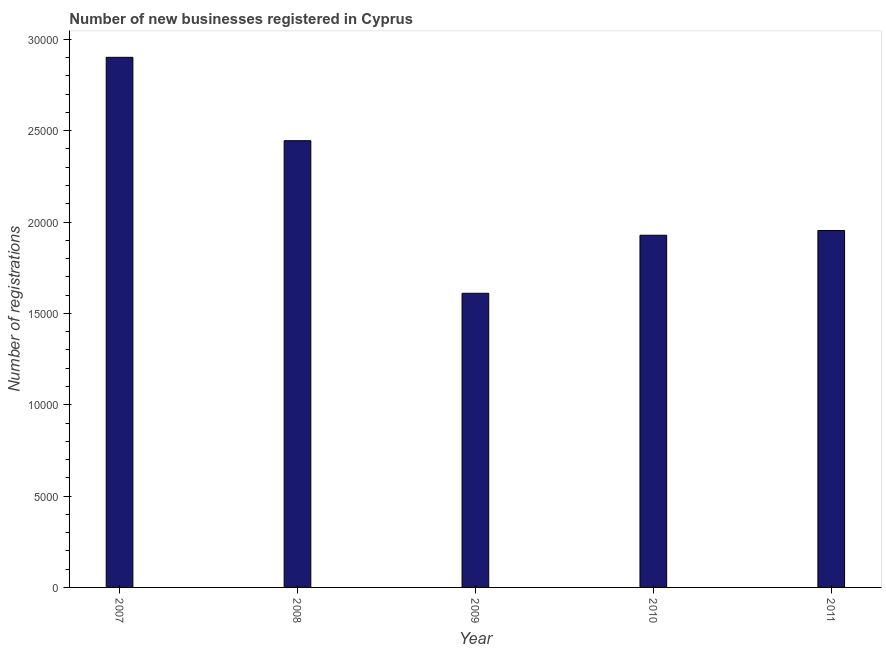Does the graph contain grids?
Your response must be concise. No. What is the title of the graph?
Provide a succinct answer. Number of new businesses registered in Cyprus. What is the label or title of the Y-axis?
Make the answer very short. Number of registrations. What is the number of new business registrations in 2010?
Give a very brief answer. 1.93e+04. Across all years, what is the maximum number of new business registrations?
Offer a very short reply. 2.90e+04. Across all years, what is the minimum number of new business registrations?
Your answer should be compact. 1.61e+04. In which year was the number of new business registrations maximum?
Provide a succinct answer. 2007. In which year was the number of new business registrations minimum?
Keep it short and to the point. 2009. What is the sum of the number of new business registrations?
Provide a succinct answer. 1.08e+05. What is the difference between the number of new business registrations in 2009 and 2011?
Your answer should be compact. -3437. What is the average number of new business registrations per year?
Your answer should be compact. 2.17e+04. What is the median number of new business registrations?
Offer a very short reply. 1.95e+04. What is the ratio of the number of new business registrations in 2007 to that in 2009?
Offer a terse response. 1.8. What is the difference between the highest and the second highest number of new business registrations?
Offer a terse response. 4563. What is the difference between the highest and the lowest number of new business registrations?
Your response must be concise. 1.29e+04. In how many years, is the number of new business registrations greater than the average number of new business registrations taken over all years?
Ensure brevity in your answer.  2. How many bars are there?
Ensure brevity in your answer.  5. Are all the bars in the graph horizontal?
Ensure brevity in your answer.  No. How many years are there in the graph?
Give a very brief answer. 5. What is the Number of registrations in 2007?
Provide a short and direct response. 2.90e+04. What is the Number of registrations in 2008?
Keep it short and to the point. 2.45e+04. What is the Number of registrations of 2009?
Ensure brevity in your answer.  1.61e+04. What is the Number of registrations in 2010?
Ensure brevity in your answer.  1.93e+04. What is the Number of registrations of 2011?
Offer a very short reply. 1.95e+04. What is the difference between the Number of registrations in 2007 and 2008?
Ensure brevity in your answer.  4563. What is the difference between the Number of registrations in 2007 and 2009?
Your answer should be very brief. 1.29e+04. What is the difference between the Number of registrations in 2007 and 2010?
Your answer should be very brief. 9738. What is the difference between the Number of registrations in 2007 and 2011?
Ensure brevity in your answer.  9478. What is the difference between the Number of registrations in 2008 and 2009?
Keep it short and to the point. 8352. What is the difference between the Number of registrations in 2008 and 2010?
Offer a terse response. 5175. What is the difference between the Number of registrations in 2008 and 2011?
Make the answer very short. 4915. What is the difference between the Number of registrations in 2009 and 2010?
Provide a succinct answer. -3177. What is the difference between the Number of registrations in 2009 and 2011?
Keep it short and to the point. -3437. What is the difference between the Number of registrations in 2010 and 2011?
Give a very brief answer. -260. What is the ratio of the Number of registrations in 2007 to that in 2008?
Your answer should be very brief. 1.19. What is the ratio of the Number of registrations in 2007 to that in 2009?
Offer a terse response. 1.8. What is the ratio of the Number of registrations in 2007 to that in 2010?
Offer a very short reply. 1.5. What is the ratio of the Number of registrations in 2007 to that in 2011?
Provide a short and direct response. 1.49. What is the ratio of the Number of registrations in 2008 to that in 2009?
Make the answer very short. 1.52. What is the ratio of the Number of registrations in 2008 to that in 2010?
Your response must be concise. 1.27. What is the ratio of the Number of registrations in 2008 to that in 2011?
Provide a succinct answer. 1.25. What is the ratio of the Number of registrations in 2009 to that in 2010?
Keep it short and to the point. 0.83. What is the ratio of the Number of registrations in 2009 to that in 2011?
Ensure brevity in your answer.  0.82. 